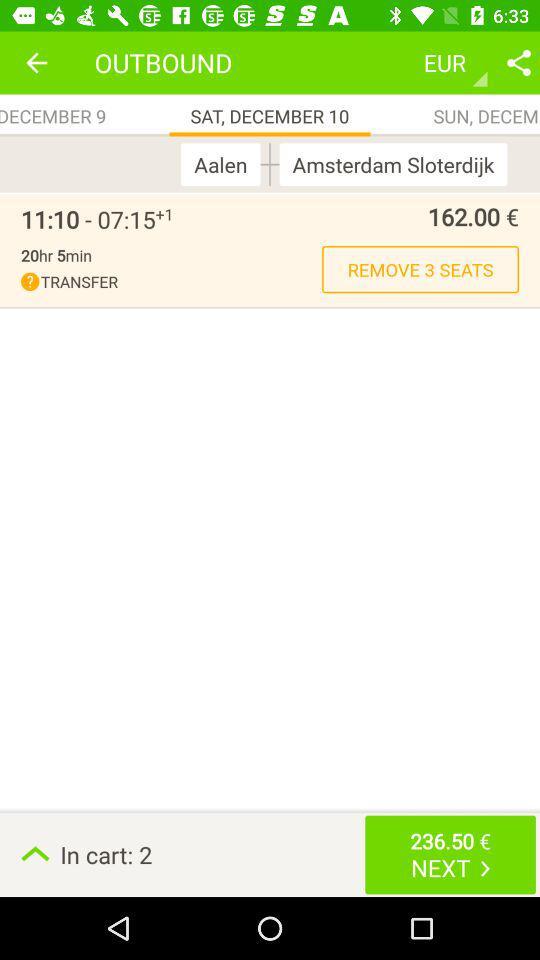How many items are in the cart? There are 2 items in the cart. 